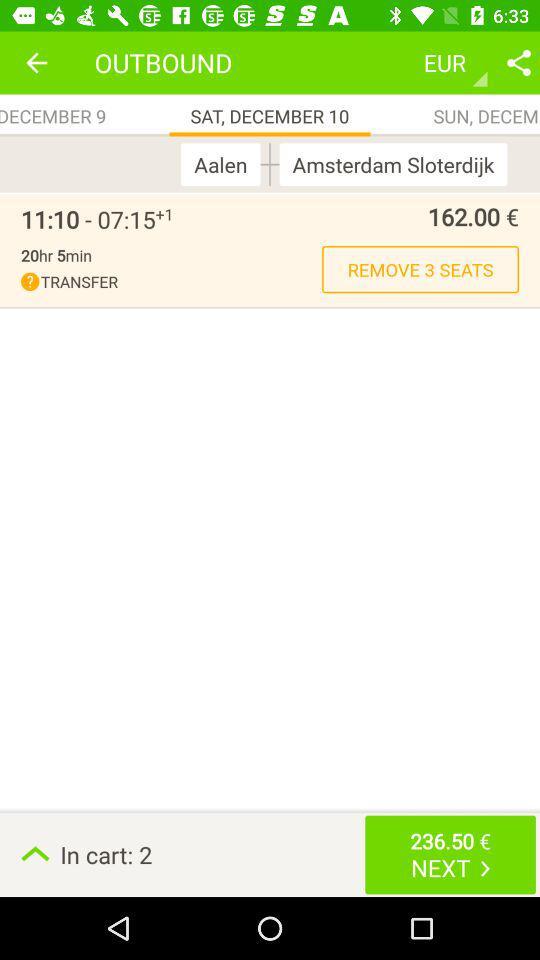How many items are in the cart? There are 2 items in the cart. 